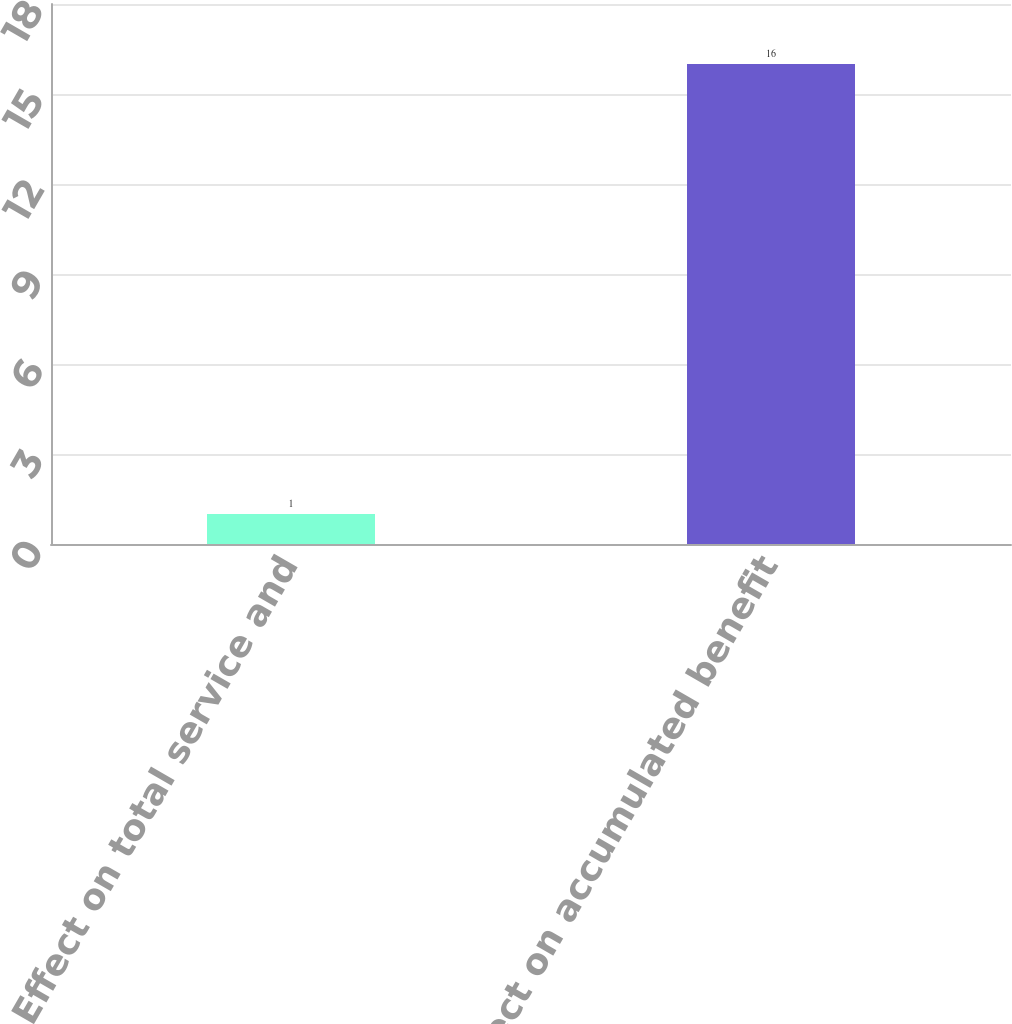<chart> <loc_0><loc_0><loc_500><loc_500><bar_chart><fcel>Effect on total service and<fcel>Effect on accumulated benefit<nl><fcel>1<fcel>16<nl></chart> 